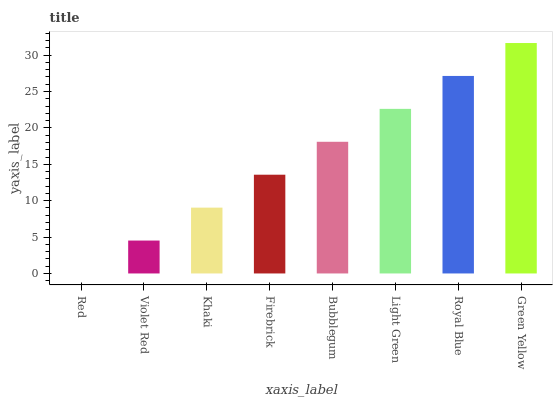Is Red the minimum?
Answer yes or no. Yes. Is Green Yellow the maximum?
Answer yes or no. Yes. Is Violet Red the minimum?
Answer yes or no. No. Is Violet Red the maximum?
Answer yes or no. No. Is Violet Red greater than Red?
Answer yes or no. Yes. Is Red less than Violet Red?
Answer yes or no. Yes. Is Red greater than Violet Red?
Answer yes or no. No. Is Violet Red less than Red?
Answer yes or no. No. Is Bubblegum the high median?
Answer yes or no. Yes. Is Firebrick the low median?
Answer yes or no. Yes. Is Red the high median?
Answer yes or no. No. Is Bubblegum the low median?
Answer yes or no. No. 